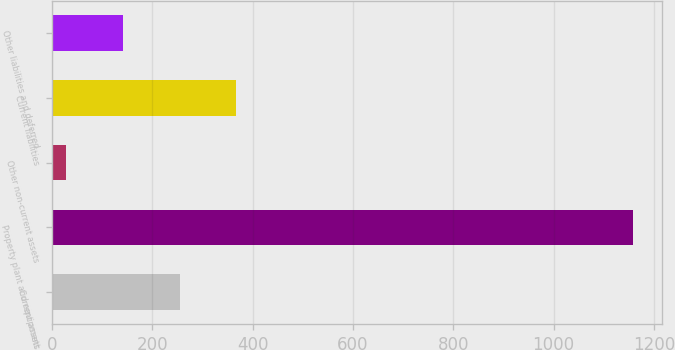<chart> <loc_0><loc_0><loc_500><loc_500><bar_chart><fcel>Current assets<fcel>Property plant and equipment<fcel>Other non-current assets<fcel>Current liabilities<fcel>Other liabilities and deferred<nl><fcel>254.44<fcel>1159<fcel>28.3<fcel>367.51<fcel>141.37<nl></chart> 